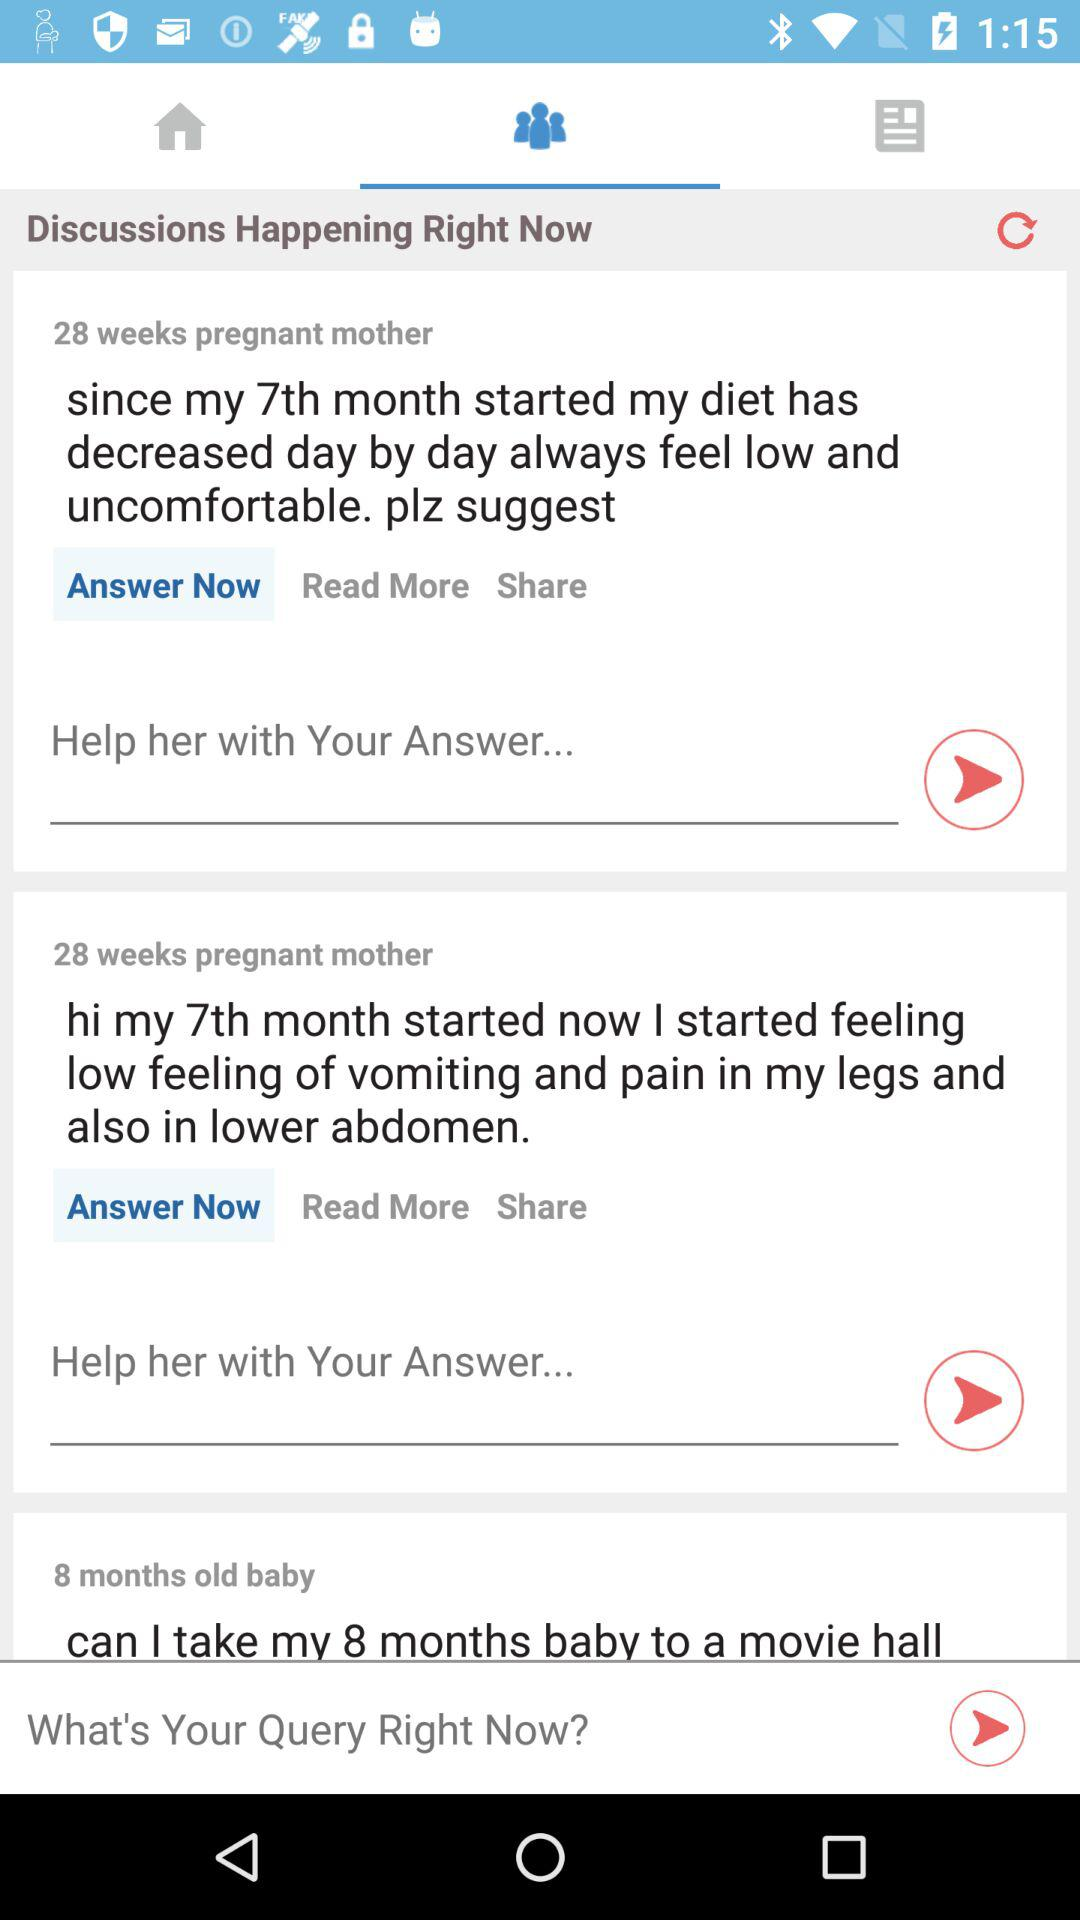Which tab is selected? The selected tab is "Groups". 